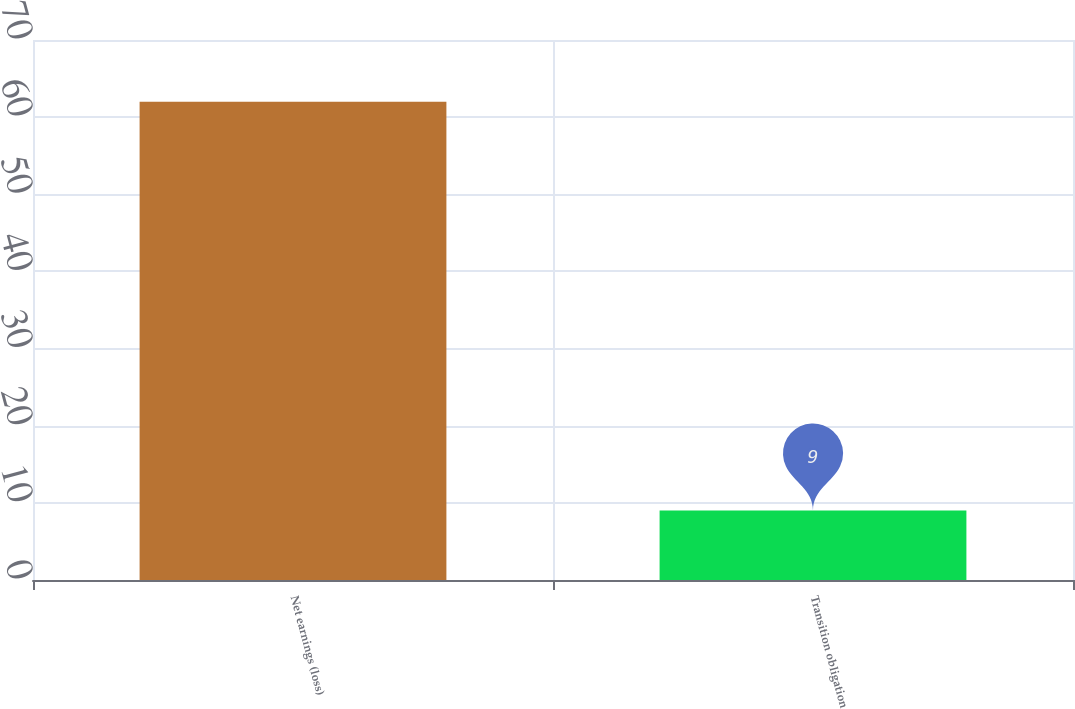Convert chart to OTSL. <chart><loc_0><loc_0><loc_500><loc_500><bar_chart><fcel>Net earnings (loss)<fcel>Transition obligation<nl><fcel>62<fcel>9<nl></chart> 